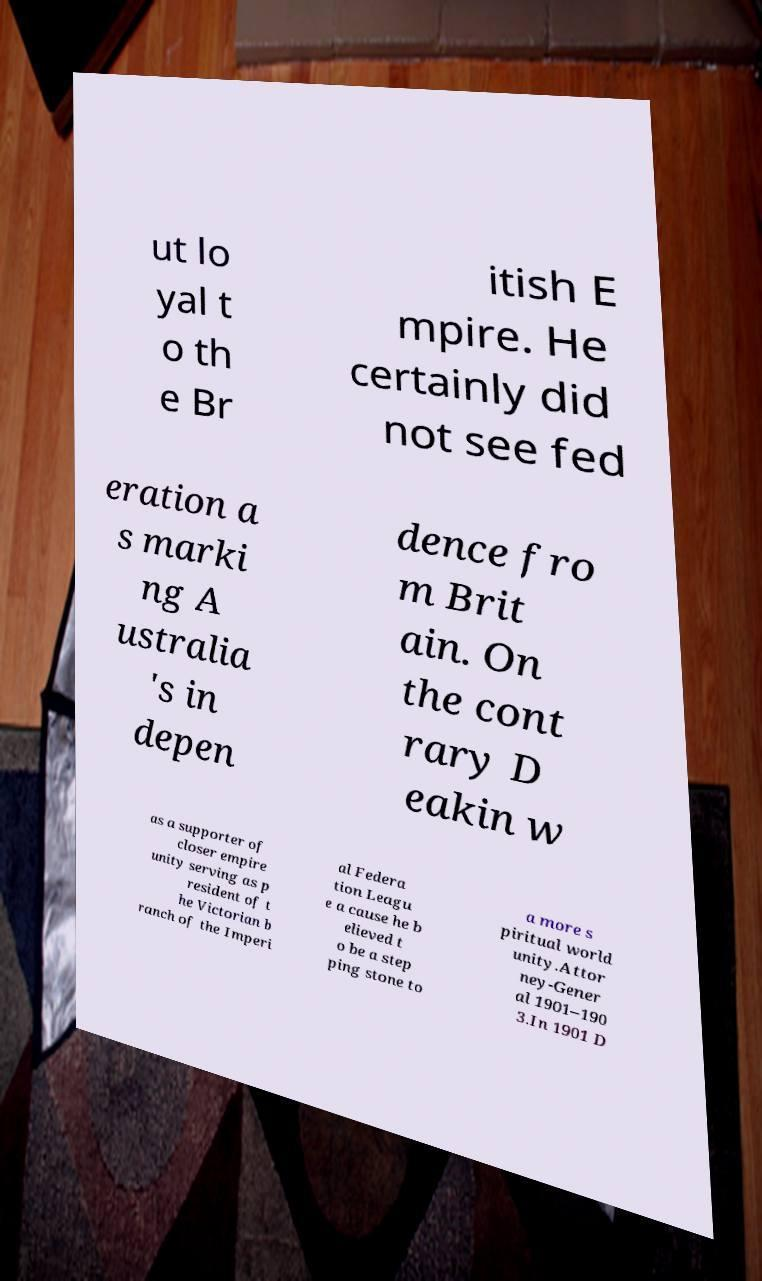Can you read and provide the text displayed in the image?This photo seems to have some interesting text. Can you extract and type it out for me? ut lo yal t o th e Br itish E mpire. He certainly did not see fed eration a s marki ng A ustralia 's in depen dence fro m Brit ain. On the cont rary D eakin w as a supporter of closer empire unity serving as p resident of t he Victorian b ranch of the Imperi al Federa tion Leagu e a cause he b elieved t o be a step ping stone to a more s piritual world unity.Attor ney-Gener al 1901–190 3.In 1901 D 